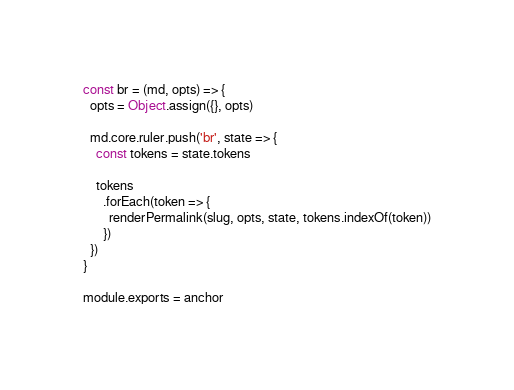Convert code to text. <code><loc_0><loc_0><loc_500><loc_500><_JavaScript_>const br = (md, opts) => {
  opts = Object.assign({}, opts)

  md.core.ruler.push('br', state => {
    const tokens = state.tokens

    tokens
      .forEach(token => {
        renderPermalink(slug, opts, state, tokens.indexOf(token))
      })
  })
}

module.exports = anchor</code> 